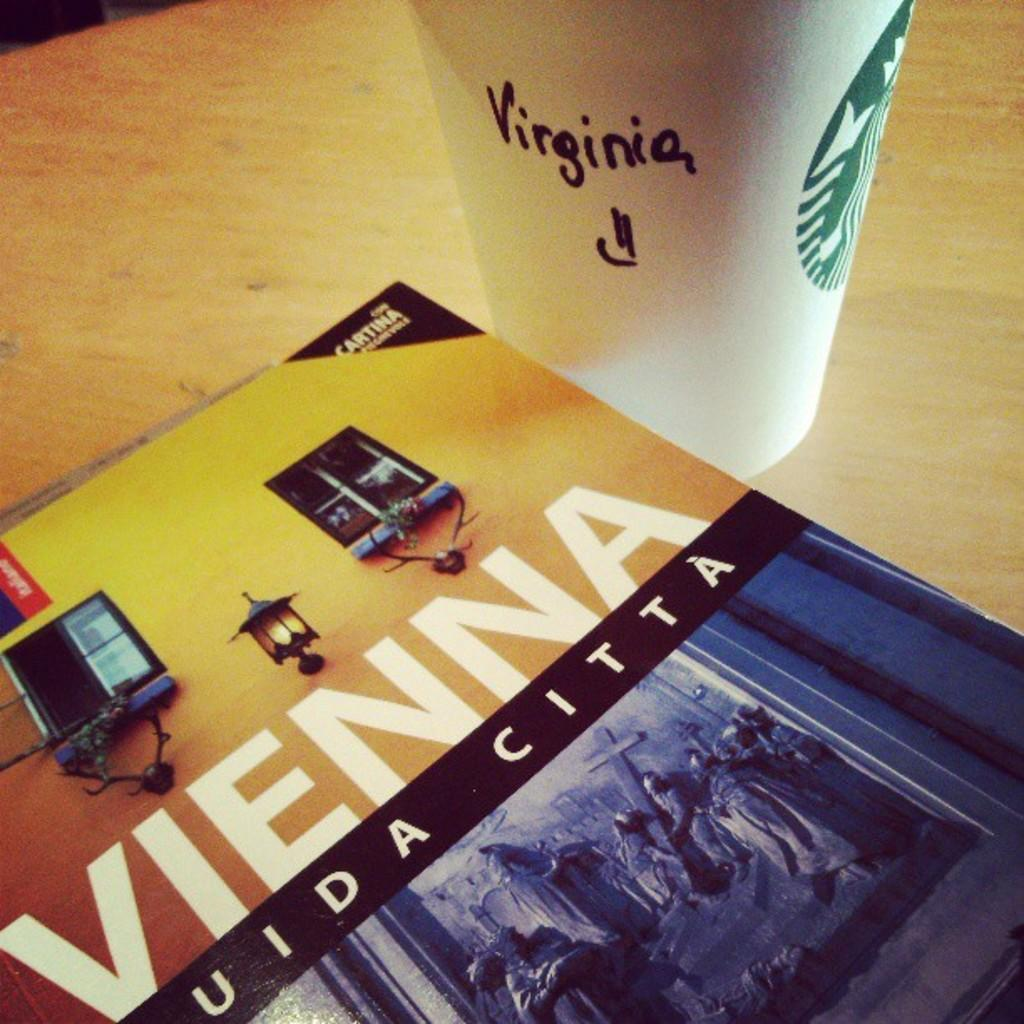<image>
Write a terse but informative summary of the picture. A Vienna book cover next to a Starbucks coffee cup. 